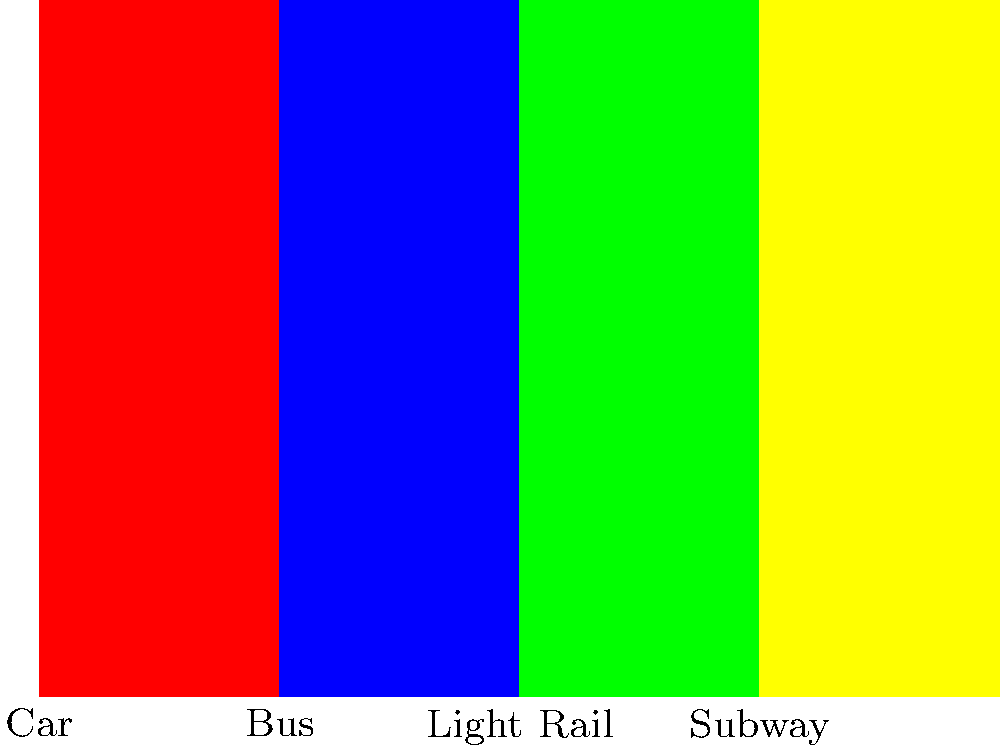Based on the bar graph comparing different transportation modes and their impact on commute times, which mode of transportation shows the most significant reduction in commute time compared to driving a car? To determine which mode of transportation shows the most significant reduction in commute time compared to driving a car, we need to:

1. Identify the commute time for driving a car: 45 minutes
2. Calculate the time difference between car and each alternative mode:
   a. Bus: 45 - 30 = 15 minutes saved
   b. Light Rail: 45 - 20 = 25 minutes saved
   c. Subway: 45 - 15 = 30 minutes saved
3. Compare the time savings:
   Bus: 15 minutes
   Light Rail: 25 minutes
   Subway: 30 minutes

The mode with the largest time savings compared to driving a car is the Subway, with a reduction of 30 minutes.
Answer: Subway 